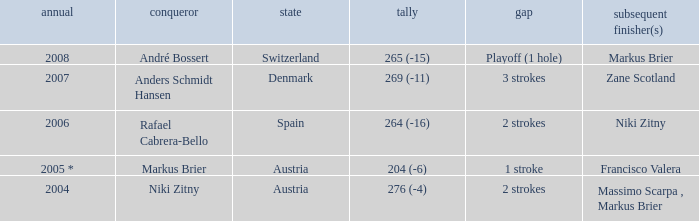What was the country when the margin was 2 strokes, and when the score was 276 (-4)? Austria. 